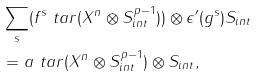<formula> <loc_0><loc_0><loc_500><loc_500>& \sum _ { s } ( f ^ { s } \ t a r ( X ^ { n } \otimes S _ { i n t } ^ { p - 1 } ) ) \otimes \epsilon ^ { \prime } ( g ^ { s } ) S _ { i n t } \\ & = a \ t a r ( X ^ { n } \otimes S _ { i n t } ^ { p - 1 } ) \otimes S _ { i n t } ,</formula> 